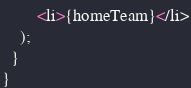Convert code to text. <code><loc_0><loc_0><loc_500><loc_500><_JavaScript_>        <li>{homeTeam}</li>
    );
  }
}
</code> 